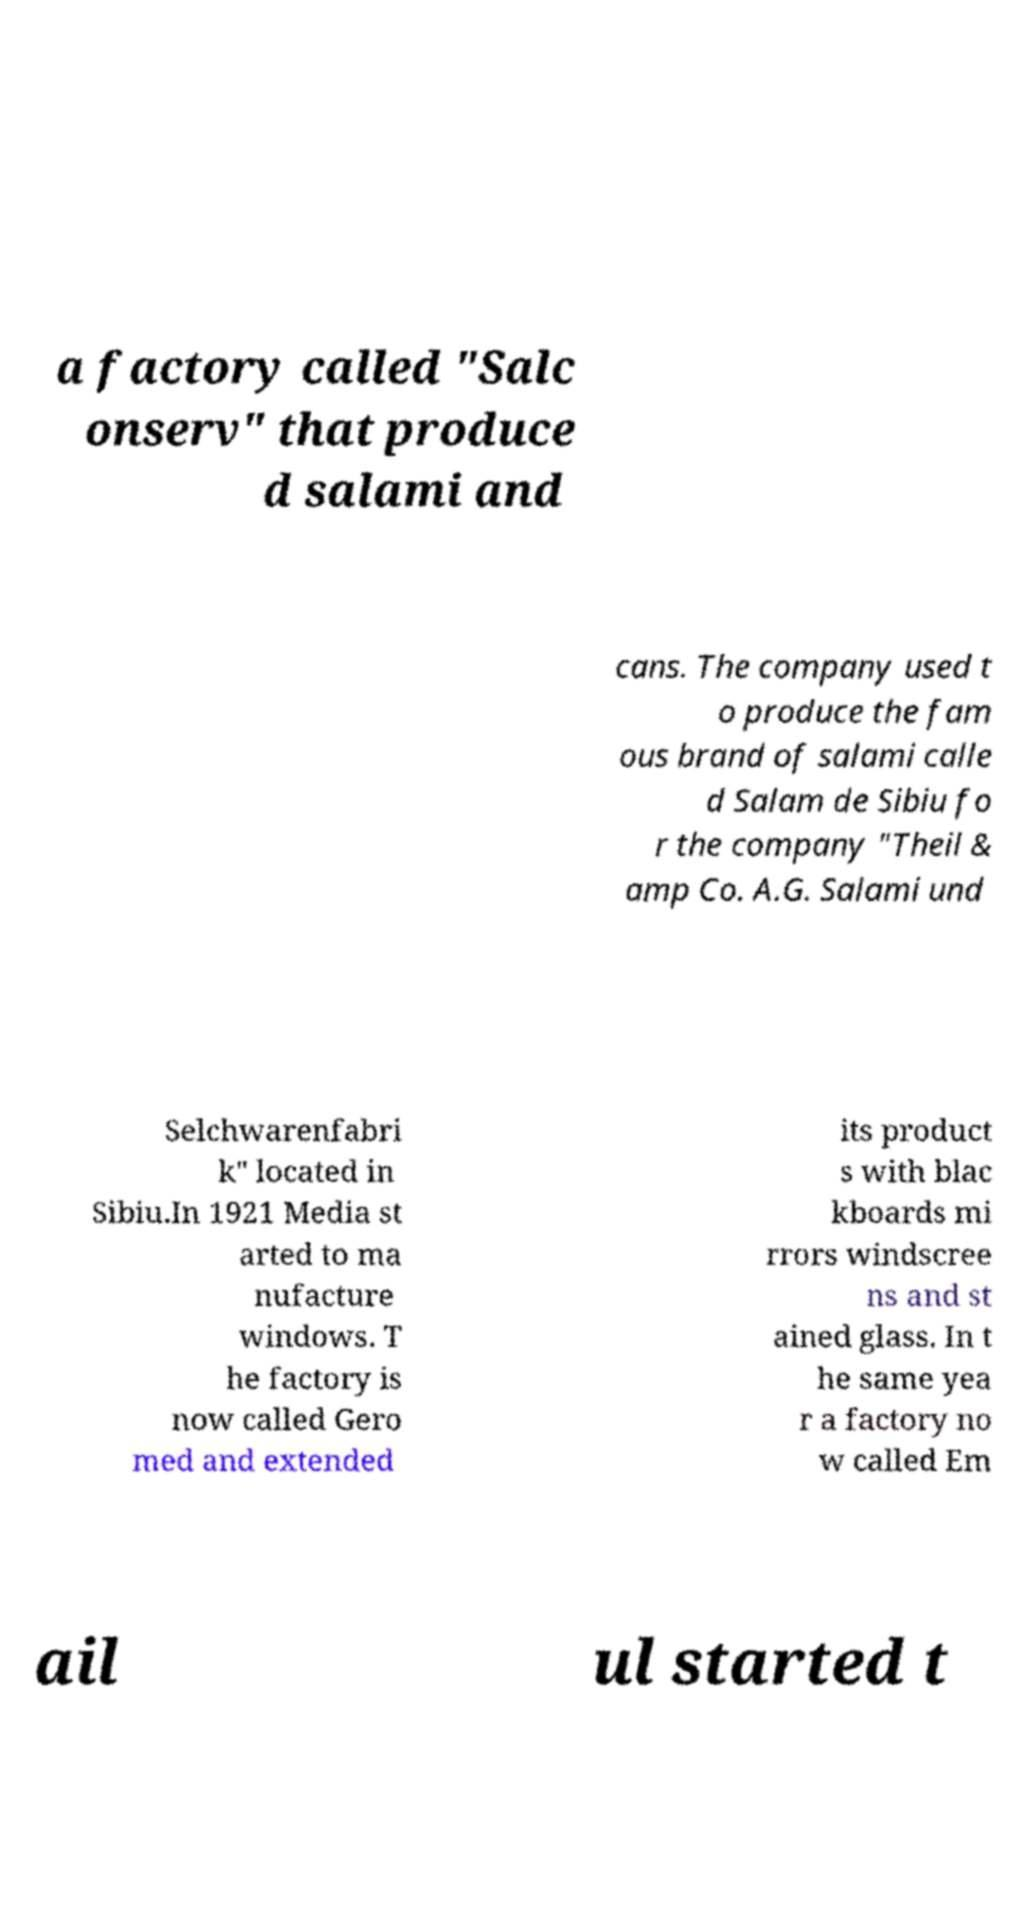Please identify and transcribe the text found in this image. a factory called "Salc onserv" that produce d salami and cans. The company used t o produce the fam ous brand of salami calle d Salam de Sibiu fo r the company "Theil & amp Co. A.G. Salami und Selchwarenfabri k" located in Sibiu.In 1921 Media st arted to ma nufacture windows. T he factory is now called Gero med and extended its product s with blac kboards mi rrors windscree ns and st ained glass. In t he same yea r a factory no w called Em ail ul started t 